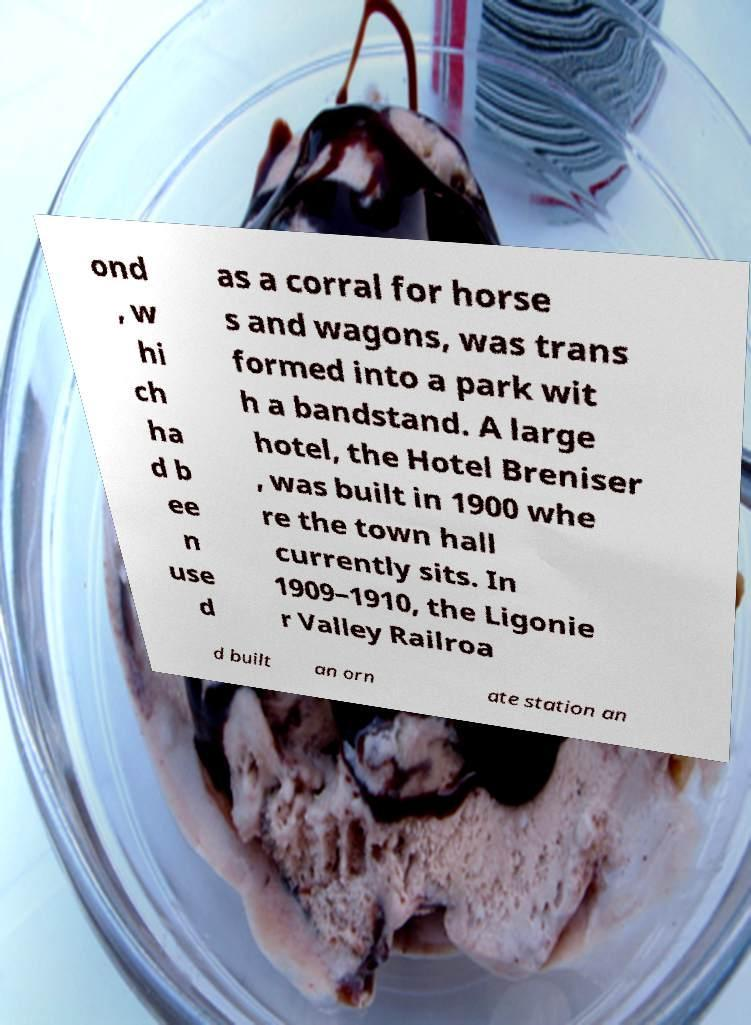Please identify and transcribe the text found in this image. ond , w hi ch ha d b ee n use d as a corral for horse s and wagons, was trans formed into a park wit h a bandstand. A large hotel, the Hotel Breniser , was built in 1900 whe re the town hall currently sits. In 1909–1910, the Ligonie r Valley Railroa d built an orn ate station an 